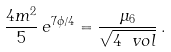<formula> <loc_0><loc_0><loc_500><loc_500>\frac { 4 m ^ { 2 } } { 5 } \, e ^ { 7 \phi / 4 } = \frac { \mu _ { 6 } } { \sqrt { 4 \ v o l } } \, .</formula> 